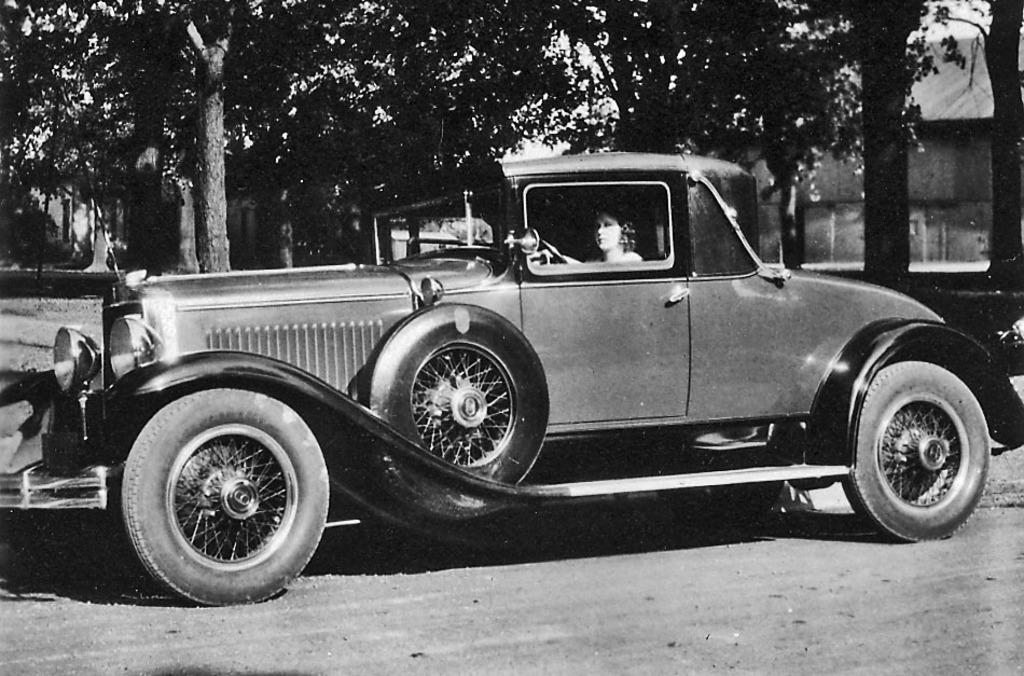What type of picture is in the image? The image contains a black and white picture. What can be seen in the picture? There is a car in the picture. Who is inside the car? A woman is sitting in the car. What is visible in the background of the picture? There are trees and a building in the background of the picture. What type of brass instrument is the woman playing in the car? There is no brass instrument present in the image; the woman is sitting in the car, but no musical instruments are visible. 